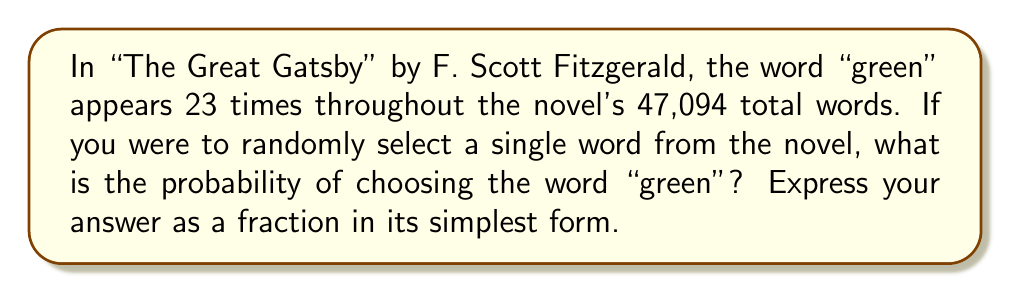Could you help me with this problem? To solve this problem, we'll follow these steps:

1. Identify the total number of words in the novel:
   Total words = 47,094

2. Identify the number of times the word "green" appears:
   Occurrences of "green" = 23

3. Calculate the probability using the formula:
   $P(\text{event}) = \frac{\text{favorable outcomes}}{\text{total possible outcomes}}$

   In this case:
   $P(\text{selecting "green"}) = \frac{\text{occurrences of "green"}}{\text{total words}}$

4. Substitute the values:
   $P(\text{selecting "green"}) = \frac{23}{47,094}$

5. Simplify the fraction:
   The fraction $\frac{23}{47,094}$ is already in its simplest form, as 23 and 47,094 have no common factors other than 1.

Therefore, the probability of randomly selecting the word "green" from "The Great Gatsby" is $\frac{23}{47,094}$.
Answer: $\frac{23}{47,094}$ 